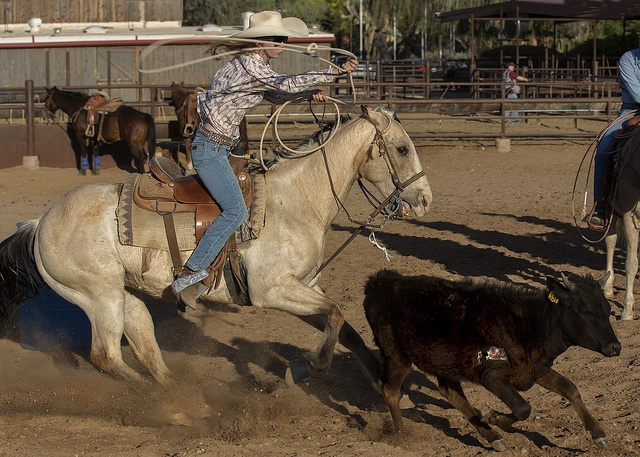Describe the objects in this image and their specific colors. I can see horse in gray, tan, and black tones, cow in gray, black, and maroon tones, people in gray, darkgray, and black tones, horse in gray, black, and maroon tones, and horse in gray, black, and tan tones in this image. 